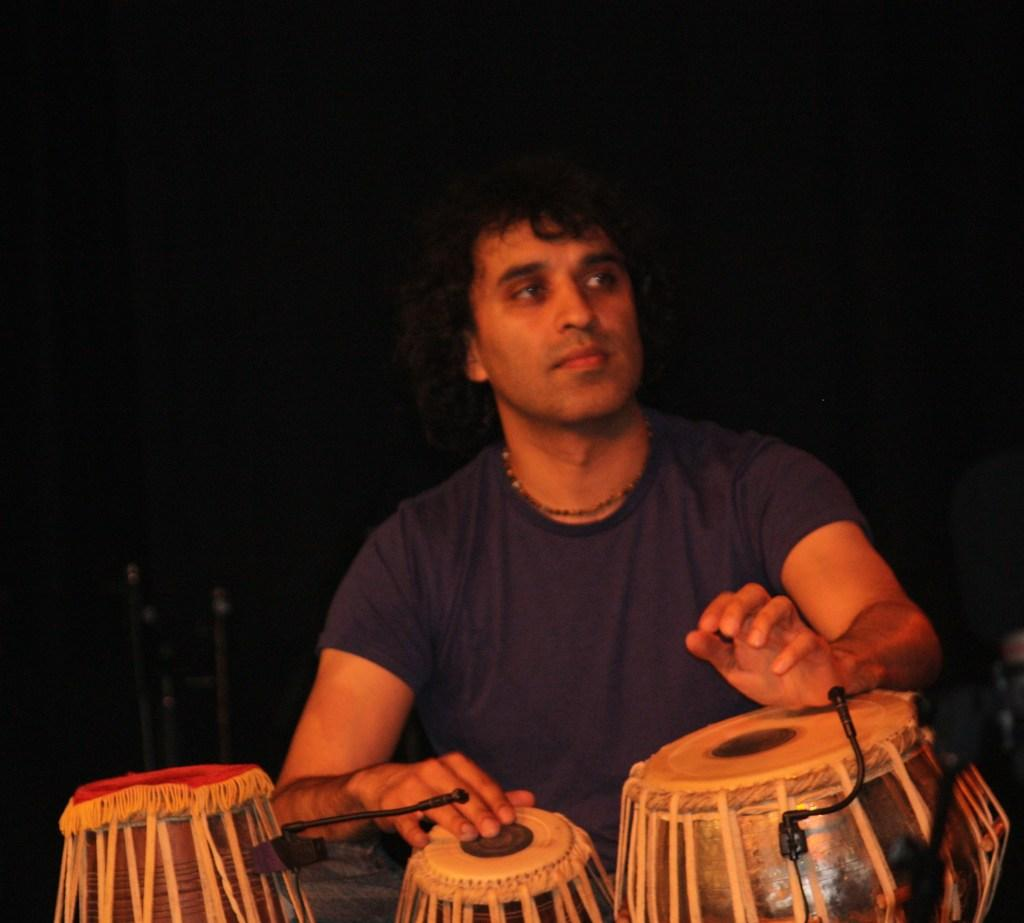Who is the main subject in the image? There is a man in the image. What is the man doing in the image? The man is playing musical instruments. What objects are present to amplify the man's sound? There are microphones in front of the man. Where is the kettle located in the image? There is no kettle present in the image. What type of toys can be seen in the image? There are no toys present in the image. 